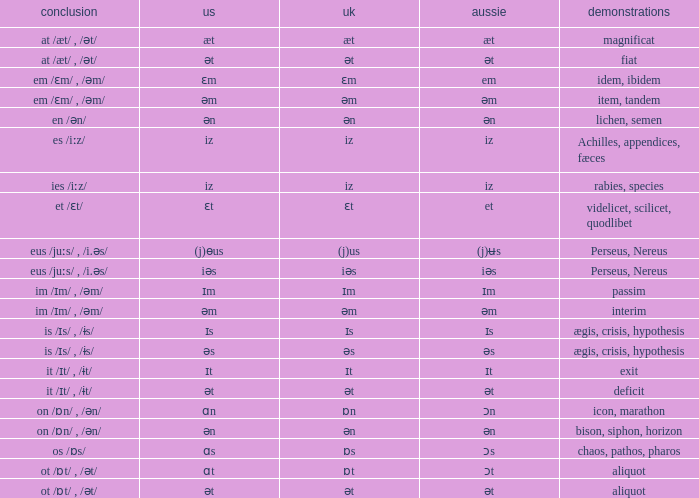Which Examples has Australian of əm? Item, tandem, interim. 